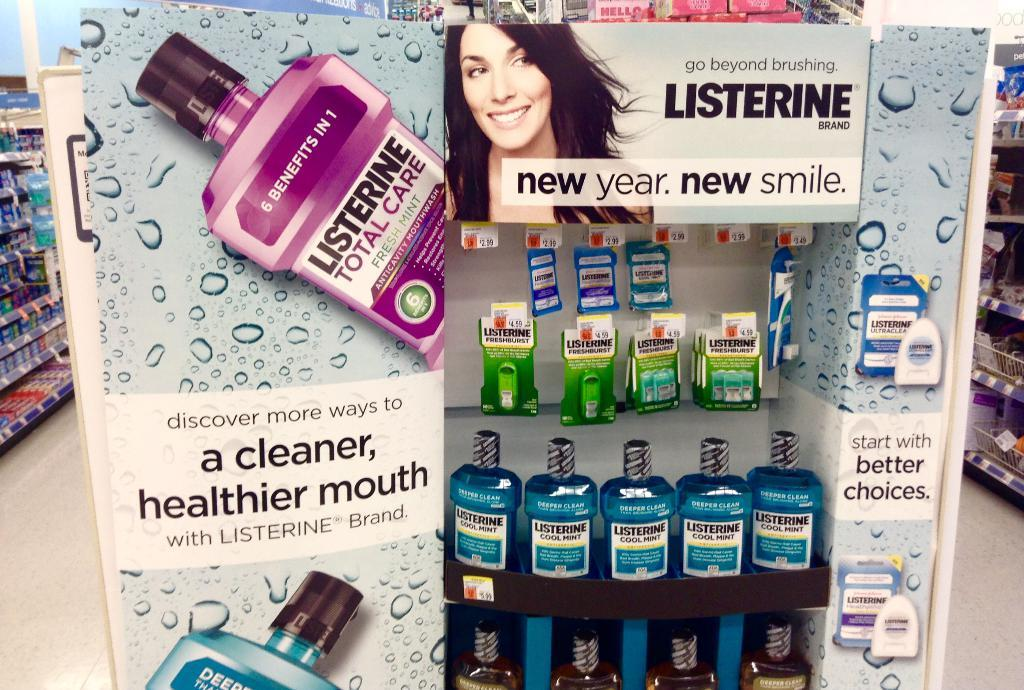<image>
Give a short and clear explanation of the subsequent image. a LISTERINE ad (saying new year. new smile.) with bottles of it being sold in a store. 